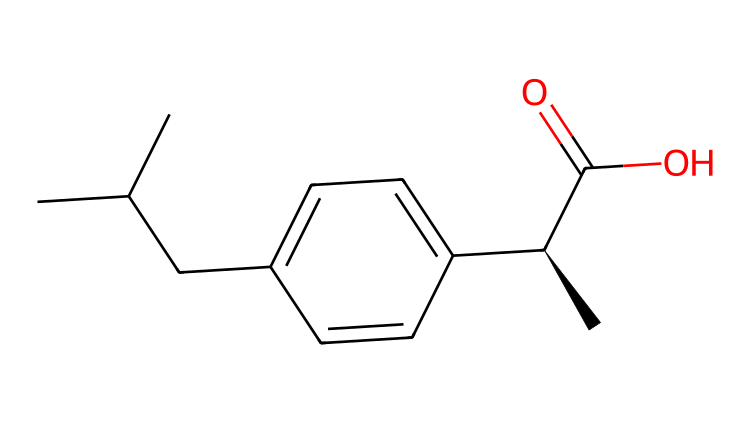how many carbon atoms are present in the chemical? By analyzing the SMILES representation, we can count the carbon atoms (C) indicated. Specifically, there are 11 carbon atoms overall.
Answer: 11 what functional group is indicated by "C(=O)O"? The segment "C(=O)O" signifies a carboxylic acid functional group, as it contains a carbonyl (C=O) and a hydroxyl group (–OH) on the same carbon.
Answer: carboxylic acid is this compound chiral? The presence of "[C@H]" in the SMILES denotes a chiral center, meaning the molecule can exist in two enantiomeric forms.
Answer: yes what is the main type of chemical bond in this compound? The compound primarily comprises covalent bonds, where atoms share electrons, evident by the structure represented by the SMILES.
Answer: covalent what is the molecular weight of this compound? To find the molecular weight, one must sum the atomic weights of all the elements in the compound: 11 carbons, 14 hydrogens, 2 oxygens yield a weight of approximately 182 grams per mole.
Answer: 182 grams per mole does this compound contain any metals? The SMILES does not indicate the presence of any metal atoms, as only carbon, hydrogen, and oxygen elements appear in the structure.
Answer: no 